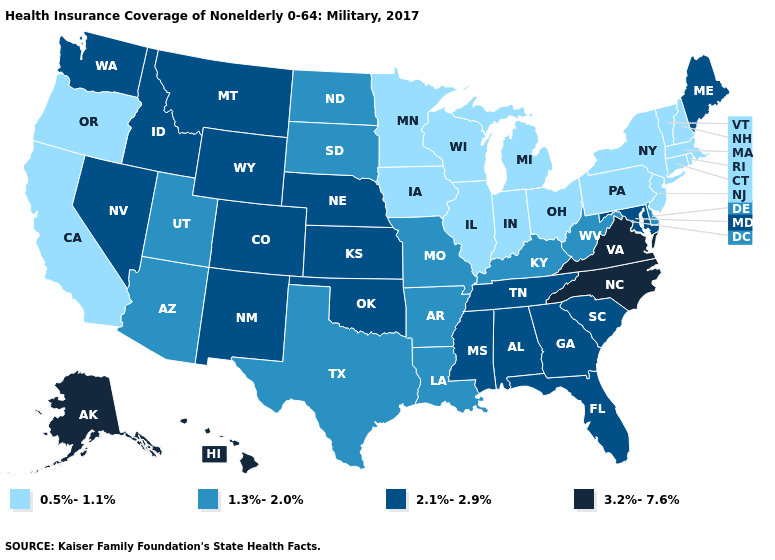Does the map have missing data?
Concise answer only. No. Does Vermont have the highest value in the USA?
Answer briefly. No. Name the states that have a value in the range 0.5%-1.1%?
Short answer required. California, Connecticut, Illinois, Indiana, Iowa, Massachusetts, Michigan, Minnesota, New Hampshire, New Jersey, New York, Ohio, Oregon, Pennsylvania, Rhode Island, Vermont, Wisconsin. Does Massachusetts have the lowest value in the USA?
Answer briefly. Yes. Which states hav the highest value in the South?
Answer briefly. North Carolina, Virginia. What is the value of Washington?
Quick response, please. 2.1%-2.9%. What is the lowest value in the USA?
Be succinct. 0.5%-1.1%. Is the legend a continuous bar?
Concise answer only. No. What is the value of California?
Short answer required. 0.5%-1.1%. Name the states that have a value in the range 0.5%-1.1%?
Be succinct. California, Connecticut, Illinois, Indiana, Iowa, Massachusetts, Michigan, Minnesota, New Hampshire, New Jersey, New York, Ohio, Oregon, Pennsylvania, Rhode Island, Vermont, Wisconsin. Does Delaware have the lowest value in the South?
Be succinct. Yes. Among the states that border Kentucky , does Missouri have the lowest value?
Quick response, please. No. What is the value of Connecticut?
Answer briefly. 0.5%-1.1%. Does Hawaii have the lowest value in the West?
Give a very brief answer. No. Does the first symbol in the legend represent the smallest category?
Short answer required. Yes. 